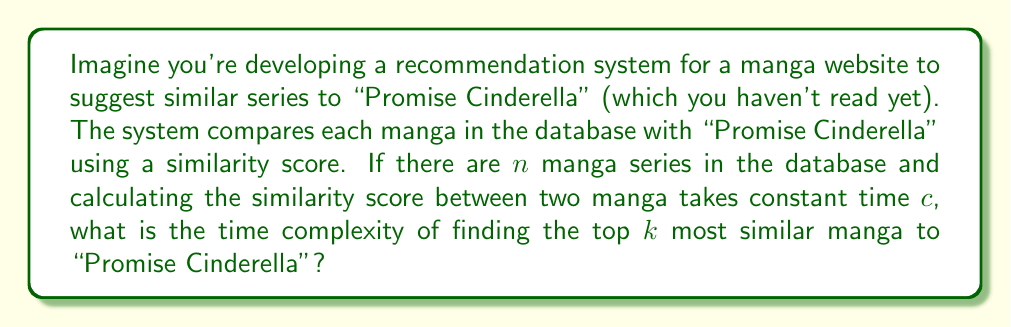Provide a solution to this math problem. Let's break this down step-by-step:

1) First, we need to calculate the similarity score between "Promise Cinderella" and every other manga in the database. This takes $O(n)$ time, where $n$ is the number of manga in the database.

2) Each similarity calculation takes constant time $c$, so the total time for all calculations is $O(cn) = O(n)$, as we drop constants in Big O notation.

3) After calculating all scores, we need to find the top $k$ most similar manga. This is equivalent to finding the $k$ largest elements in an unsorted array of size $n$.

4) The most efficient way to do this is using a min-heap of size $k$:
   - Build a min-heap with the first $k$ elements: $O(k)$
   - For each of the remaining $(n-k)$ elements:
     - Compare with the root of the heap: $O(1)$
     - If larger, remove root and insert new element: $O(\log k)$

5) The time complexity of this heap operation is:

   $$O(k + (n-k)\log k) = O(n\log k)$$

6) The total time complexity is the sum of calculating similarities and finding the top $k$:

   $$O(n) + O(n\log k) = O(n\log k)$$

   Note that when $k$ is significantly smaller than $n$, this is more efficient than sorting all scores, which would take $O(n\log n)$.
Answer: The time complexity of finding the top $k$ most similar manga to "Promise Cinderella" out of $n$ total manga is $O(n\log k)$. 